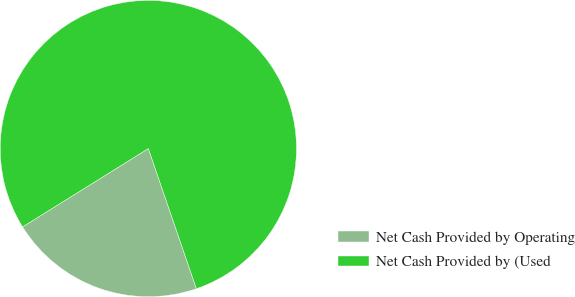<chart> <loc_0><loc_0><loc_500><loc_500><pie_chart><fcel>Net Cash Provided by Operating<fcel>Net Cash Provided by (Used<nl><fcel>21.39%<fcel>78.61%<nl></chart> 